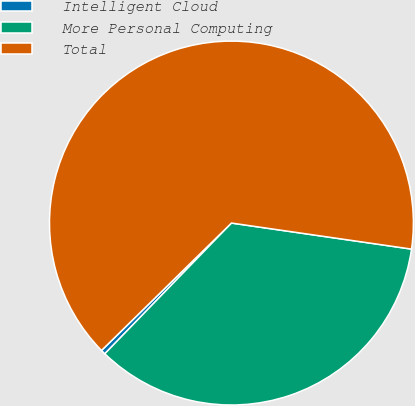Convert chart to OTSL. <chart><loc_0><loc_0><loc_500><loc_500><pie_chart><fcel>Intelligent Cloud<fcel>More Personal Computing<fcel>Total<nl><fcel>0.41%<fcel>34.96%<fcel>64.63%<nl></chart> 